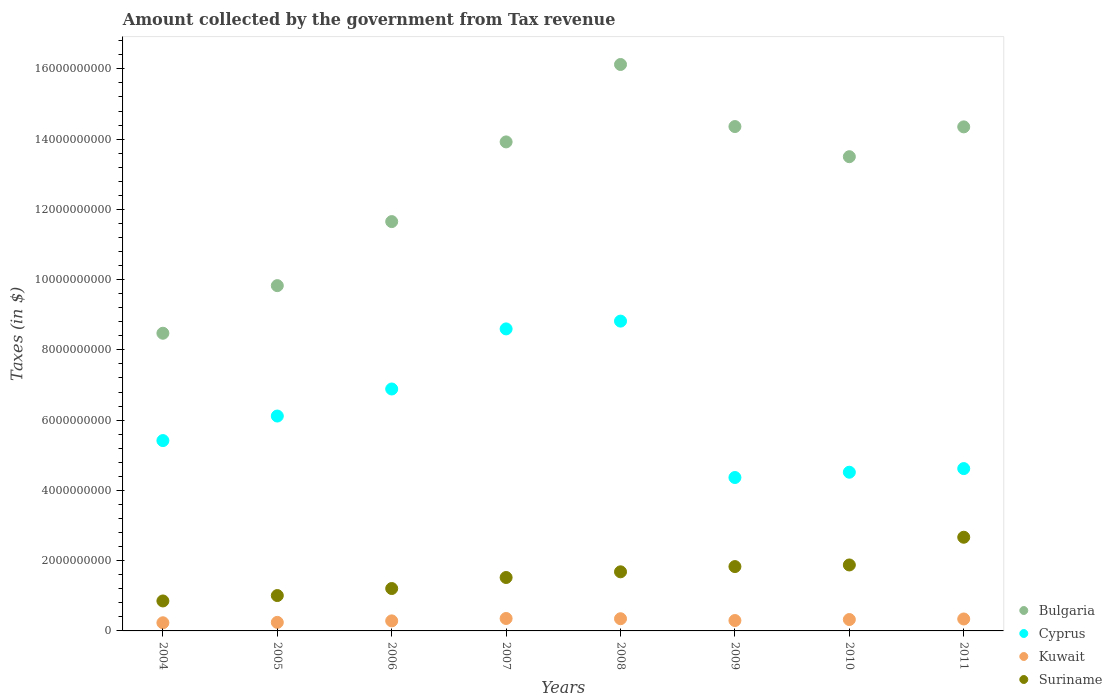Is the number of dotlines equal to the number of legend labels?
Provide a short and direct response. Yes. What is the amount collected by the government from tax revenue in Cyprus in 2008?
Offer a terse response. 8.82e+09. Across all years, what is the maximum amount collected by the government from tax revenue in Kuwait?
Provide a short and direct response. 3.54e+08. Across all years, what is the minimum amount collected by the government from tax revenue in Cyprus?
Provide a succinct answer. 4.37e+09. In which year was the amount collected by the government from tax revenue in Kuwait maximum?
Your answer should be compact. 2007. In which year was the amount collected by the government from tax revenue in Bulgaria minimum?
Offer a very short reply. 2004. What is the total amount collected by the government from tax revenue in Kuwait in the graph?
Your answer should be compact. 2.42e+09. What is the difference between the amount collected by the government from tax revenue in Cyprus in 2004 and that in 2005?
Offer a very short reply. -6.99e+08. What is the difference between the amount collected by the government from tax revenue in Cyprus in 2011 and the amount collected by the government from tax revenue in Kuwait in 2010?
Ensure brevity in your answer.  4.30e+09. What is the average amount collected by the government from tax revenue in Suriname per year?
Offer a terse response. 1.58e+09. In the year 2011, what is the difference between the amount collected by the government from tax revenue in Kuwait and amount collected by the government from tax revenue in Suriname?
Your response must be concise. -2.33e+09. In how many years, is the amount collected by the government from tax revenue in Cyprus greater than 15200000000 $?
Ensure brevity in your answer.  0. What is the ratio of the amount collected by the government from tax revenue in Cyprus in 2006 to that in 2010?
Give a very brief answer. 1.52. Is the amount collected by the government from tax revenue in Bulgaria in 2009 less than that in 2010?
Give a very brief answer. No. What is the difference between the highest and the second highest amount collected by the government from tax revenue in Suriname?
Ensure brevity in your answer.  7.89e+08. What is the difference between the highest and the lowest amount collected by the government from tax revenue in Suriname?
Your answer should be very brief. 1.81e+09. In how many years, is the amount collected by the government from tax revenue in Kuwait greater than the average amount collected by the government from tax revenue in Kuwait taken over all years?
Give a very brief answer. 4. Is the sum of the amount collected by the government from tax revenue in Cyprus in 2005 and 2008 greater than the maximum amount collected by the government from tax revenue in Suriname across all years?
Make the answer very short. Yes. Is it the case that in every year, the sum of the amount collected by the government from tax revenue in Kuwait and amount collected by the government from tax revenue in Cyprus  is greater than the amount collected by the government from tax revenue in Bulgaria?
Make the answer very short. No. Does the amount collected by the government from tax revenue in Bulgaria monotonically increase over the years?
Provide a succinct answer. No. Is the amount collected by the government from tax revenue in Cyprus strictly greater than the amount collected by the government from tax revenue in Kuwait over the years?
Offer a terse response. Yes. Is the amount collected by the government from tax revenue in Bulgaria strictly less than the amount collected by the government from tax revenue in Suriname over the years?
Your response must be concise. No. What is the difference between two consecutive major ticks on the Y-axis?
Your answer should be very brief. 2.00e+09. Are the values on the major ticks of Y-axis written in scientific E-notation?
Offer a terse response. No. Does the graph contain any zero values?
Offer a very short reply. No. Does the graph contain grids?
Provide a succinct answer. No. What is the title of the graph?
Your answer should be very brief. Amount collected by the government from Tax revenue. What is the label or title of the X-axis?
Make the answer very short. Years. What is the label or title of the Y-axis?
Give a very brief answer. Taxes (in $). What is the Taxes (in $) of Bulgaria in 2004?
Provide a succinct answer. 8.47e+09. What is the Taxes (in $) in Cyprus in 2004?
Your answer should be compact. 5.42e+09. What is the Taxes (in $) in Kuwait in 2004?
Provide a succinct answer. 2.32e+08. What is the Taxes (in $) in Suriname in 2004?
Your answer should be compact. 8.53e+08. What is the Taxes (in $) in Bulgaria in 2005?
Offer a very short reply. 9.83e+09. What is the Taxes (in $) of Cyprus in 2005?
Offer a terse response. 6.12e+09. What is the Taxes (in $) of Kuwait in 2005?
Ensure brevity in your answer.  2.43e+08. What is the Taxes (in $) of Suriname in 2005?
Offer a very short reply. 1.01e+09. What is the Taxes (in $) in Bulgaria in 2006?
Give a very brief answer. 1.17e+1. What is the Taxes (in $) of Cyprus in 2006?
Offer a terse response. 6.89e+09. What is the Taxes (in $) in Kuwait in 2006?
Give a very brief answer. 2.86e+08. What is the Taxes (in $) in Suriname in 2006?
Provide a succinct answer. 1.21e+09. What is the Taxes (in $) of Bulgaria in 2007?
Your response must be concise. 1.39e+1. What is the Taxes (in $) of Cyprus in 2007?
Give a very brief answer. 8.60e+09. What is the Taxes (in $) of Kuwait in 2007?
Your answer should be very brief. 3.54e+08. What is the Taxes (in $) of Suriname in 2007?
Offer a very short reply. 1.52e+09. What is the Taxes (in $) of Bulgaria in 2008?
Your response must be concise. 1.61e+1. What is the Taxes (in $) of Cyprus in 2008?
Provide a succinct answer. 8.82e+09. What is the Taxes (in $) of Kuwait in 2008?
Make the answer very short. 3.47e+08. What is the Taxes (in $) of Suriname in 2008?
Offer a very short reply. 1.68e+09. What is the Taxes (in $) of Bulgaria in 2009?
Your answer should be very brief. 1.44e+1. What is the Taxes (in $) in Cyprus in 2009?
Give a very brief answer. 4.37e+09. What is the Taxes (in $) of Kuwait in 2009?
Offer a terse response. 2.96e+08. What is the Taxes (in $) of Suriname in 2009?
Offer a terse response. 1.83e+09. What is the Taxes (in $) of Bulgaria in 2010?
Make the answer very short. 1.35e+1. What is the Taxes (in $) of Cyprus in 2010?
Offer a very short reply. 4.52e+09. What is the Taxes (in $) of Kuwait in 2010?
Provide a short and direct response. 3.24e+08. What is the Taxes (in $) in Suriname in 2010?
Provide a succinct answer. 1.88e+09. What is the Taxes (in $) of Bulgaria in 2011?
Provide a short and direct response. 1.43e+1. What is the Taxes (in $) of Cyprus in 2011?
Offer a very short reply. 4.62e+09. What is the Taxes (in $) in Kuwait in 2011?
Give a very brief answer. 3.40e+08. What is the Taxes (in $) in Suriname in 2011?
Your response must be concise. 2.67e+09. Across all years, what is the maximum Taxes (in $) in Bulgaria?
Ensure brevity in your answer.  1.61e+1. Across all years, what is the maximum Taxes (in $) in Cyprus?
Provide a short and direct response. 8.82e+09. Across all years, what is the maximum Taxes (in $) of Kuwait?
Your response must be concise. 3.54e+08. Across all years, what is the maximum Taxes (in $) in Suriname?
Provide a short and direct response. 2.67e+09. Across all years, what is the minimum Taxes (in $) in Bulgaria?
Your answer should be compact. 8.47e+09. Across all years, what is the minimum Taxes (in $) in Cyprus?
Make the answer very short. 4.37e+09. Across all years, what is the minimum Taxes (in $) of Kuwait?
Give a very brief answer. 2.32e+08. Across all years, what is the minimum Taxes (in $) in Suriname?
Ensure brevity in your answer.  8.53e+08. What is the total Taxes (in $) of Bulgaria in the graph?
Ensure brevity in your answer.  1.02e+11. What is the total Taxes (in $) of Cyprus in the graph?
Your answer should be very brief. 4.93e+1. What is the total Taxes (in $) of Kuwait in the graph?
Give a very brief answer. 2.42e+09. What is the total Taxes (in $) of Suriname in the graph?
Provide a succinct answer. 1.26e+1. What is the difference between the Taxes (in $) of Bulgaria in 2004 and that in 2005?
Provide a short and direct response. -1.36e+09. What is the difference between the Taxes (in $) of Cyprus in 2004 and that in 2005?
Give a very brief answer. -6.99e+08. What is the difference between the Taxes (in $) of Kuwait in 2004 and that in 2005?
Provide a short and direct response. -1.10e+07. What is the difference between the Taxes (in $) in Suriname in 2004 and that in 2005?
Provide a short and direct response. -1.54e+08. What is the difference between the Taxes (in $) of Bulgaria in 2004 and that in 2006?
Offer a very short reply. -3.18e+09. What is the difference between the Taxes (in $) in Cyprus in 2004 and that in 2006?
Make the answer very short. -1.47e+09. What is the difference between the Taxes (in $) in Kuwait in 2004 and that in 2006?
Your response must be concise. -5.40e+07. What is the difference between the Taxes (in $) in Suriname in 2004 and that in 2006?
Your answer should be compact. -3.54e+08. What is the difference between the Taxes (in $) in Bulgaria in 2004 and that in 2007?
Provide a short and direct response. -5.45e+09. What is the difference between the Taxes (in $) of Cyprus in 2004 and that in 2007?
Your answer should be very brief. -3.18e+09. What is the difference between the Taxes (in $) in Kuwait in 2004 and that in 2007?
Keep it short and to the point. -1.22e+08. What is the difference between the Taxes (in $) of Suriname in 2004 and that in 2007?
Offer a very short reply. -6.68e+08. What is the difference between the Taxes (in $) in Bulgaria in 2004 and that in 2008?
Make the answer very short. -7.65e+09. What is the difference between the Taxes (in $) of Cyprus in 2004 and that in 2008?
Make the answer very short. -3.40e+09. What is the difference between the Taxes (in $) of Kuwait in 2004 and that in 2008?
Provide a short and direct response. -1.15e+08. What is the difference between the Taxes (in $) in Suriname in 2004 and that in 2008?
Provide a short and direct response. -8.29e+08. What is the difference between the Taxes (in $) in Bulgaria in 2004 and that in 2009?
Your answer should be compact. -5.88e+09. What is the difference between the Taxes (in $) in Cyprus in 2004 and that in 2009?
Ensure brevity in your answer.  1.05e+09. What is the difference between the Taxes (in $) of Kuwait in 2004 and that in 2009?
Provide a short and direct response. -6.40e+07. What is the difference between the Taxes (in $) in Suriname in 2004 and that in 2009?
Provide a succinct answer. -9.79e+08. What is the difference between the Taxes (in $) in Bulgaria in 2004 and that in 2010?
Give a very brief answer. -5.03e+09. What is the difference between the Taxes (in $) of Cyprus in 2004 and that in 2010?
Make the answer very short. 9.01e+08. What is the difference between the Taxes (in $) in Kuwait in 2004 and that in 2010?
Your answer should be very brief. -9.20e+07. What is the difference between the Taxes (in $) of Suriname in 2004 and that in 2010?
Offer a very short reply. -1.02e+09. What is the difference between the Taxes (in $) of Bulgaria in 2004 and that in 2011?
Your response must be concise. -5.87e+09. What is the difference between the Taxes (in $) in Cyprus in 2004 and that in 2011?
Offer a very short reply. 7.97e+08. What is the difference between the Taxes (in $) of Kuwait in 2004 and that in 2011?
Offer a terse response. -1.08e+08. What is the difference between the Taxes (in $) in Suriname in 2004 and that in 2011?
Your answer should be compact. -1.81e+09. What is the difference between the Taxes (in $) in Bulgaria in 2005 and that in 2006?
Provide a succinct answer. -1.82e+09. What is the difference between the Taxes (in $) of Cyprus in 2005 and that in 2006?
Your answer should be very brief. -7.70e+08. What is the difference between the Taxes (in $) of Kuwait in 2005 and that in 2006?
Provide a short and direct response. -4.30e+07. What is the difference between the Taxes (in $) of Suriname in 2005 and that in 2006?
Ensure brevity in your answer.  -2.00e+08. What is the difference between the Taxes (in $) of Bulgaria in 2005 and that in 2007?
Your answer should be very brief. -4.09e+09. What is the difference between the Taxes (in $) of Cyprus in 2005 and that in 2007?
Your response must be concise. -2.48e+09. What is the difference between the Taxes (in $) in Kuwait in 2005 and that in 2007?
Ensure brevity in your answer.  -1.11e+08. What is the difference between the Taxes (in $) of Suriname in 2005 and that in 2007?
Make the answer very short. -5.14e+08. What is the difference between the Taxes (in $) in Bulgaria in 2005 and that in 2008?
Your answer should be compact. -6.30e+09. What is the difference between the Taxes (in $) in Cyprus in 2005 and that in 2008?
Ensure brevity in your answer.  -2.70e+09. What is the difference between the Taxes (in $) of Kuwait in 2005 and that in 2008?
Ensure brevity in your answer.  -1.04e+08. What is the difference between the Taxes (in $) of Suriname in 2005 and that in 2008?
Your answer should be very brief. -6.76e+08. What is the difference between the Taxes (in $) in Bulgaria in 2005 and that in 2009?
Make the answer very short. -4.53e+09. What is the difference between the Taxes (in $) of Cyprus in 2005 and that in 2009?
Offer a very short reply. 1.75e+09. What is the difference between the Taxes (in $) of Kuwait in 2005 and that in 2009?
Keep it short and to the point. -5.30e+07. What is the difference between the Taxes (in $) in Suriname in 2005 and that in 2009?
Ensure brevity in your answer.  -8.25e+08. What is the difference between the Taxes (in $) of Bulgaria in 2005 and that in 2010?
Offer a very short reply. -3.67e+09. What is the difference between the Taxes (in $) in Cyprus in 2005 and that in 2010?
Keep it short and to the point. 1.60e+09. What is the difference between the Taxes (in $) in Kuwait in 2005 and that in 2010?
Ensure brevity in your answer.  -8.10e+07. What is the difference between the Taxes (in $) of Suriname in 2005 and that in 2010?
Make the answer very short. -8.71e+08. What is the difference between the Taxes (in $) in Bulgaria in 2005 and that in 2011?
Offer a terse response. -4.52e+09. What is the difference between the Taxes (in $) of Cyprus in 2005 and that in 2011?
Offer a very short reply. 1.50e+09. What is the difference between the Taxes (in $) of Kuwait in 2005 and that in 2011?
Provide a succinct answer. -9.70e+07. What is the difference between the Taxes (in $) in Suriname in 2005 and that in 2011?
Your answer should be compact. -1.66e+09. What is the difference between the Taxes (in $) in Bulgaria in 2006 and that in 2007?
Give a very brief answer. -2.27e+09. What is the difference between the Taxes (in $) in Cyprus in 2006 and that in 2007?
Make the answer very short. -1.71e+09. What is the difference between the Taxes (in $) of Kuwait in 2006 and that in 2007?
Make the answer very short. -6.80e+07. What is the difference between the Taxes (in $) of Suriname in 2006 and that in 2007?
Offer a very short reply. -3.14e+08. What is the difference between the Taxes (in $) of Bulgaria in 2006 and that in 2008?
Make the answer very short. -4.47e+09. What is the difference between the Taxes (in $) of Cyprus in 2006 and that in 2008?
Provide a short and direct response. -1.93e+09. What is the difference between the Taxes (in $) of Kuwait in 2006 and that in 2008?
Your answer should be compact. -6.10e+07. What is the difference between the Taxes (in $) of Suriname in 2006 and that in 2008?
Offer a terse response. -4.76e+08. What is the difference between the Taxes (in $) in Bulgaria in 2006 and that in 2009?
Offer a very short reply. -2.71e+09. What is the difference between the Taxes (in $) of Cyprus in 2006 and that in 2009?
Your answer should be compact. 2.52e+09. What is the difference between the Taxes (in $) in Kuwait in 2006 and that in 2009?
Ensure brevity in your answer.  -1.00e+07. What is the difference between the Taxes (in $) in Suriname in 2006 and that in 2009?
Provide a short and direct response. -6.25e+08. What is the difference between the Taxes (in $) of Bulgaria in 2006 and that in 2010?
Give a very brief answer. -1.85e+09. What is the difference between the Taxes (in $) of Cyprus in 2006 and that in 2010?
Your answer should be very brief. 2.37e+09. What is the difference between the Taxes (in $) of Kuwait in 2006 and that in 2010?
Offer a terse response. -3.80e+07. What is the difference between the Taxes (in $) in Suriname in 2006 and that in 2010?
Your answer should be very brief. -6.71e+08. What is the difference between the Taxes (in $) of Bulgaria in 2006 and that in 2011?
Give a very brief answer. -2.70e+09. What is the difference between the Taxes (in $) in Cyprus in 2006 and that in 2011?
Keep it short and to the point. 2.27e+09. What is the difference between the Taxes (in $) in Kuwait in 2006 and that in 2011?
Your answer should be very brief. -5.40e+07. What is the difference between the Taxes (in $) in Suriname in 2006 and that in 2011?
Make the answer very short. -1.46e+09. What is the difference between the Taxes (in $) in Bulgaria in 2007 and that in 2008?
Make the answer very short. -2.20e+09. What is the difference between the Taxes (in $) in Cyprus in 2007 and that in 2008?
Your response must be concise. -2.21e+08. What is the difference between the Taxes (in $) of Suriname in 2007 and that in 2008?
Make the answer very short. -1.62e+08. What is the difference between the Taxes (in $) of Bulgaria in 2007 and that in 2009?
Your answer should be compact. -4.37e+08. What is the difference between the Taxes (in $) in Cyprus in 2007 and that in 2009?
Give a very brief answer. 4.23e+09. What is the difference between the Taxes (in $) in Kuwait in 2007 and that in 2009?
Give a very brief answer. 5.80e+07. What is the difference between the Taxes (in $) in Suriname in 2007 and that in 2009?
Your answer should be very brief. -3.11e+08. What is the difference between the Taxes (in $) in Bulgaria in 2007 and that in 2010?
Give a very brief answer. 4.21e+08. What is the difference between the Taxes (in $) of Cyprus in 2007 and that in 2010?
Give a very brief answer. 4.08e+09. What is the difference between the Taxes (in $) of Kuwait in 2007 and that in 2010?
Your answer should be compact. 3.00e+07. What is the difference between the Taxes (in $) of Suriname in 2007 and that in 2010?
Offer a terse response. -3.57e+08. What is the difference between the Taxes (in $) in Bulgaria in 2007 and that in 2011?
Give a very brief answer. -4.28e+08. What is the difference between the Taxes (in $) in Cyprus in 2007 and that in 2011?
Your response must be concise. 3.98e+09. What is the difference between the Taxes (in $) of Kuwait in 2007 and that in 2011?
Provide a short and direct response. 1.40e+07. What is the difference between the Taxes (in $) of Suriname in 2007 and that in 2011?
Your answer should be very brief. -1.15e+09. What is the difference between the Taxes (in $) in Bulgaria in 2008 and that in 2009?
Offer a terse response. 1.77e+09. What is the difference between the Taxes (in $) in Cyprus in 2008 and that in 2009?
Make the answer very short. 4.45e+09. What is the difference between the Taxes (in $) of Kuwait in 2008 and that in 2009?
Your response must be concise. 5.10e+07. What is the difference between the Taxes (in $) of Suriname in 2008 and that in 2009?
Keep it short and to the point. -1.49e+08. What is the difference between the Taxes (in $) of Bulgaria in 2008 and that in 2010?
Your answer should be compact. 2.62e+09. What is the difference between the Taxes (in $) in Cyprus in 2008 and that in 2010?
Provide a short and direct response. 4.30e+09. What is the difference between the Taxes (in $) of Kuwait in 2008 and that in 2010?
Your answer should be compact. 2.30e+07. What is the difference between the Taxes (in $) in Suriname in 2008 and that in 2010?
Offer a terse response. -1.95e+08. What is the difference between the Taxes (in $) in Bulgaria in 2008 and that in 2011?
Your response must be concise. 1.78e+09. What is the difference between the Taxes (in $) in Cyprus in 2008 and that in 2011?
Ensure brevity in your answer.  4.20e+09. What is the difference between the Taxes (in $) of Suriname in 2008 and that in 2011?
Your answer should be very brief. -9.84e+08. What is the difference between the Taxes (in $) in Bulgaria in 2009 and that in 2010?
Your response must be concise. 8.58e+08. What is the difference between the Taxes (in $) of Cyprus in 2009 and that in 2010?
Offer a terse response. -1.51e+08. What is the difference between the Taxes (in $) of Kuwait in 2009 and that in 2010?
Offer a terse response. -2.80e+07. What is the difference between the Taxes (in $) of Suriname in 2009 and that in 2010?
Keep it short and to the point. -4.60e+07. What is the difference between the Taxes (in $) of Bulgaria in 2009 and that in 2011?
Your answer should be very brief. 9.09e+06. What is the difference between the Taxes (in $) in Cyprus in 2009 and that in 2011?
Give a very brief answer. -2.54e+08. What is the difference between the Taxes (in $) of Kuwait in 2009 and that in 2011?
Ensure brevity in your answer.  -4.40e+07. What is the difference between the Taxes (in $) in Suriname in 2009 and that in 2011?
Provide a short and direct response. -8.35e+08. What is the difference between the Taxes (in $) of Bulgaria in 2010 and that in 2011?
Offer a terse response. -8.49e+08. What is the difference between the Taxes (in $) in Cyprus in 2010 and that in 2011?
Offer a terse response. -1.04e+08. What is the difference between the Taxes (in $) in Kuwait in 2010 and that in 2011?
Make the answer very short. -1.60e+07. What is the difference between the Taxes (in $) of Suriname in 2010 and that in 2011?
Offer a terse response. -7.89e+08. What is the difference between the Taxes (in $) of Bulgaria in 2004 and the Taxes (in $) of Cyprus in 2005?
Offer a terse response. 2.36e+09. What is the difference between the Taxes (in $) in Bulgaria in 2004 and the Taxes (in $) in Kuwait in 2005?
Your response must be concise. 8.23e+09. What is the difference between the Taxes (in $) in Bulgaria in 2004 and the Taxes (in $) in Suriname in 2005?
Your response must be concise. 7.47e+09. What is the difference between the Taxes (in $) of Cyprus in 2004 and the Taxes (in $) of Kuwait in 2005?
Your response must be concise. 5.18e+09. What is the difference between the Taxes (in $) in Cyprus in 2004 and the Taxes (in $) in Suriname in 2005?
Ensure brevity in your answer.  4.41e+09. What is the difference between the Taxes (in $) of Kuwait in 2004 and the Taxes (in $) of Suriname in 2005?
Ensure brevity in your answer.  -7.75e+08. What is the difference between the Taxes (in $) in Bulgaria in 2004 and the Taxes (in $) in Cyprus in 2006?
Ensure brevity in your answer.  1.59e+09. What is the difference between the Taxes (in $) of Bulgaria in 2004 and the Taxes (in $) of Kuwait in 2006?
Your answer should be compact. 8.19e+09. What is the difference between the Taxes (in $) of Bulgaria in 2004 and the Taxes (in $) of Suriname in 2006?
Offer a terse response. 7.27e+09. What is the difference between the Taxes (in $) of Cyprus in 2004 and the Taxes (in $) of Kuwait in 2006?
Make the answer very short. 5.13e+09. What is the difference between the Taxes (in $) in Cyprus in 2004 and the Taxes (in $) in Suriname in 2006?
Give a very brief answer. 4.21e+09. What is the difference between the Taxes (in $) of Kuwait in 2004 and the Taxes (in $) of Suriname in 2006?
Offer a very short reply. -9.75e+08. What is the difference between the Taxes (in $) in Bulgaria in 2004 and the Taxes (in $) in Cyprus in 2007?
Give a very brief answer. -1.24e+08. What is the difference between the Taxes (in $) in Bulgaria in 2004 and the Taxes (in $) in Kuwait in 2007?
Your answer should be very brief. 8.12e+09. What is the difference between the Taxes (in $) in Bulgaria in 2004 and the Taxes (in $) in Suriname in 2007?
Your answer should be compact. 6.95e+09. What is the difference between the Taxes (in $) in Cyprus in 2004 and the Taxes (in $) in Kuwait in 2007?
Give a very brief answer. 5.06e+09. What is the difference between the Taxes (in $) of Cyprus in 2004 and the Taxes (in $) of Suriname in 2007?
Keep it short and to the point. 3.90e+09. What is the difference between the Taxes (in $) of Kuwait in 2004 and the Taxes (in $) of Suriname in 2007?
Your answer should be compact. -1.29e+09. What is the difference between the Taxes (in $) in Bulgaria in 2004 and the Taxes (in $) in Cyprus in 2008?
Give a very brief answer. -3.45e+08. What is the difference between the Taxes (in $) of Bulgaria in 2004 and the Taxes (in $) of Kuwait in 2008?
Your response must be concise. 8.13e+09. What is the difference between the Taxes (in $) in Bulgaria in 2004 and the Taxes (in $) in Suriname in 2008?
Provide a short and direct response. 6.79e+09. What is the difference between the Taxes (in $) of Cyprus in 2004 and the Taxes (in $) of Kuwait in 2008?
Your response must be concise. 5.07e+09. What is the difference between the Taxes (in $) of Cyprus in 2004 and the Taxes (in $) of Suriname in 2008?
Keep it short and to the point. 3.74e+09. What is the difference between the Taxes (in $) in Kuwait in 2004 and the Taxes (in $) in Suriname in 2008?
Offer a very short reply. -1.45e+09. What is the difference between the Taxes (in $) in Bulgaria in 2004 and the Taxes (in $) in Cyprus in 2009?
Ensure brevity in your answer.  4.11e+09. What is the difference between the Taxes (in $) in Bulgaria in 2004 and the Taxes (in $) in Kuwait in 2009?
Offer a terse response. 8.18e+09. What is the difference between the Taxes (in $) in Bulgaria in 2004 and the Taxes (in $) in Suriname in 2009?
Give a very brief answer. 6.64e+09. What is the difference between the Taxes (in $) in Cyprus in 2004 and the Taxes (in $) in Kuwait in 2009?
Offer a terse response. 5.12e+09. What is the difference between the Taxes (in $) of Cyprus in 2004 and the Taxes (in $) of Suriname in 2009?
Ensure brevity in your answer.  3.59e+09. What is the difference between the Taxes (in $) of Kuwait in 2004 and the Taxes (in $) of Suriname in 2009?
Your response must be concise. -1.60e+09. What is the difference between the Taxes (in $) in Bulgaria in 2004 and the Taxes (in $) in Cyprus in 2010?
Provide a short and direct response. 3.96e+09. What is the difference between the Taxes (in $) in Bulgaria in 2004 and the Taxes (in $) in Kuwait in 2010?
Your answer should be very brief. 8.15e+09. What is the difference between the Taxes (in $) in Bulgaria in 2004 and the Taxes (in $) in Suriname in 2010?
Provide a succinct answer. 6.60e+09. What is the difference between the Taxes (in $) in Cyprus in 2004 and the Taxes (in $) in Kuwait in 2010?
Your response must be concise. 5.09e+09. What is the difference between the Taxes (in $) in Cyprus in 2004 and the Taxes (in $) in Suriname in 2010?
Your answer should be very brief. 3.54e+09. What is the difference between the Taxes (in $) in Kuwait in 2004 and the Taxes (in $) in Suriname in 2010?
Provide a short and direct response. -1.65e+09. What is the difference between the Taxes (in $) in Bulgaria in 2004 and the Taxes (in $) in Cyprus in 2011?
Your answer should be very brief. 3.85e+09. What is the difference between the Taxes (in $) in Bulgaria in 2004 and the Taxes (in $) in Kuwait in 2011?
Your answer should be compact. 8.13e+09. What is the difference between the Taxes (in $) of Bulgaria in 2004 and the Taxes (in $) of Suriname in 2011?
Your answer should be compact. 5.81e+09. What is the difference between the Taxes (in $) in Cyprus in 2004 and the Taxes (in $) in Kuwait in 2011?
Keep it short and to the point. 5.08e+09. What is the difference between the Taxes (in $) of Cyprus in 2004 and the Taxes (in $) of Suriname in 2011?
Provide a short and direct response. 2.75e+09. What is the difference between the Taxes (in $) of Kuwait in 2004 and the Taxes (in $) of Suriname in 2011?
Give a very brief answer. -2.43e+09. What is the difference between the Taxes (in $) in Bulgaria in 2005 and the Taxes (in $) in Cyprus in 2006?
Offer a very short reply. 2.94e+09. What is the difference between the Taxes (in $) of Bulgaria in 2005 and the Taxes (in $) of Kuwait in 2006?
Offer a very short reply. 9.54e+09. What is the difference between the Taxes (in $) in Bulgaria in 2005 and the Taxes (in $) in Suriname in 2006?
Your response must be concise. 8.62e+09. What is the difference between the Taxes (in $) of Cyprus in 2005 and the Taxes (in $) of Kuwait in 2006?
Give a very brief answer. 5.83e+09. What is the difference between the Taxes (in $) in Cyprus in 2005 and the Taxes (in $) in Suriname in 2006?
Ensure brevity in your answer.  4.91e+09. What is the difference between the Taxes (in $) in Kuwait in 2005 and the Taxes (in $) in Suriname in 2006?
Your answer should be very brief. -9.64e+08. What is the difference between the Taxes (in $) in Bulgaria in 2005 and the Taxes (in $) in Cyprus in 2007?
Provide a succinct answer. 1.23e+09. What is the difference between the Taxes (in $) in Bulgaria in 2005 and the Taxes (in $) in Kuwait in 2007?
Provide a succinct answer. 9.48e+09. What is the difference between the Taxes (in $) in Bulgaria in 2005 and the Taxes (in $) in Suriname in 2007?
Ensure brevity in your answer.  8.31e+09. What is the difference between the Taxes (in $) of Cyprus in 2005 and the Taxes (in $) of Kuwait in 2007?
Offer a terse response. 5.76e+09. What is the difference between the Taxes (in $) in Cyprus in 2005 and the Taxes (in $) in Suriname in 2007?
Ensure brevity in your answer.  4.60e+09. What is the difference between the Taxes (in $) of Kuwait in 2005 and the Taxes (in $) of Suriname in 2007?
Your answer should be compact. -1.28e+09. What is the difference between the Taxes (in $) in Bulgaria in 2005 and the Taxes (in $) in Cyprus in 2008?
Ensure brevity in your answer.  1.01e+09. What is the difference between the Taxes (in $) of Bulgaria in 2005 and the Taxes (in $) of Kuwait in 2008?
Keep it short and to the point. 9.48e+09. What is the difference between the Taxes (in $) in Bulgaria in 2005 and the Taxes (in $) in Suriname in 2008?
Ensure brevity in your answer.  8.15e+09. What is the difference between the Taxes (in $) of Cyprus in 2005 and the Taxes (in $) of Kuwait in 2008?
Offer a terse response. 5.77e+09. What is the difference between the Taxes (in $) in Cyprus in 2005 and the Taxes (in $) in Suriname in 2008?
Provide a short and direct response. 4.43e+09. What is the difference between the Taxes (in $) of Kuwait in 2005 and the Taxes (in $) of Suriname in 2008?
Your answer should be very brief. -1.44e+09. What is the difference between the Taxes (in $) in Bulgaria in 2005 and the Taxes (in $) in Cyprus in 2009?
Provide a succinct answer. 5.46e+09. What is the difference between the Taxes (in $) in Bulgaria in 2005 and the Taxes (in $) in Kuwait in 2009?
Ensure brevity in your answer.  9.53e+09. What is the difference between the Taxes (in $) in Bulgaria in 2005 and the Taxes (in $) in Suriname in 2009?
Keep it short and to the point. 8.00e+09. What is the difference between the Taxes (in $) of Cyprus in 2005 and the Taxes (in $) of Kuwait in 2009?
Ensure brevity in your answer.  5.82e+09. What is the difference between the Taxes (in $) of Cyprus in 2005 and the Taxes (in $) of Suriname in 2009?
Make the answer very short. 4.29e+09. What is the difference between the Taxes (in $) in Kuwait in 2005 and the Taxes (in $) in Suriname in 2009?
Offer a very short reply. -1.59e+09. What is the difference between the Taxes (in $) in Bulgaria in 2005 and the Taxes (in $) in Cyprus in 2010?
Provide a short and direct response. 5.31e+09. What is the difference between the Taxes (in $) of Bulgaria in 2005 and the Taxes (in $) of Kuwait in 2010?
Make the answer very short. 9.51e+09. What is the difference between the Taxes (in $) in Bulgaria in 2005 and the Taxes (in $) in Suriname in 2010?
Provide a succinct answer. 7.95e+09. What is the difference between the Taxes (in $) of Cyprus in 2005 and the Taxes (in $) of Kuwait in 2010?
Offer a terse response. 5.79e+09. What is the difference between the Taxes (in $) in Cyprus in 2005 and the Taxes (in $) in Suriname in 2010?
Keep it short and to the point. 4.24e+09. What is the difference between the Taxes (in $) of Kuwait in 2005 and the Taxes (in $) of Suriname in 2010?
Ensure brevity in your answer.  -1.63e+09. What is the difference between the Taxes (in $) in Bulgaria in 2005 and the Taxes (in $) in Cyprus in 2011?
Keep it short and to the point. 5.21e+09. What is the difference between the Taxes (in $) in Bulgaria in 2005 and the Taxes (in $) in Kuwait in 2011?
Keep it short and to the point. 9.49e+09. What is the difference between the Taxes (in $) of Bulgaria in 2005 and the Taxes (in $) of Suriname in 2011?
Keep it short and to the point. 7.16e+09. What is the difference between the Taxes (in $) in Cyprus in 2005 and the Taxes (in $) in Kuwait in 2011?
Your answer should be very brief. 5.78e+09. What is the difference between the Taxes (in $) in Cyprus in 2005 and the Taxes (in $) in Suriname in 2011?
Make the answer very short. 3.45e+09. What is the difference between the Taxes (in $) of Kuwait in 2005 and the Taxes (in $) of Suriname in 2011?
Your answer should be compact. -2.42e+09. What is the difference between the Taxes (in $) in Bulgaria in 2006 and the Taxes (in $) in Cyprus in 2007?
Provide a succinct answer. 3.05e+09. What is the difference between the Taxes (in $) of Bulgaria in 2006 and the Taxes (in $) of Kuwait in 2007?
Provide a short and direct response. 1.13e+1. What is the difference between the Taxes (in $) in Bulgaria in 2006 and the Taxes (in $) in Suriname in 2007?
Keep it short and to the point. 1.01e+1. What is the difference between the Taxes (in $) in Cyprus in 2006 and the Taxes (in $) in Kuwait in 2007?
Your answer should be compact. 6.53e+09. What is the difference between the Taxes (in $) of Cyprus in 2006 and the Taxes (in $) of Suriname in 2007?
Offer a terse response. 5.37e+09. What is the difference between the Taxes (in $) in Kuwait in 2006 and the Taxes (in $) in Suriname in 2007?
Offer a terse response. -1.23e+09. What is the difference between the Taxes (in $) in Bulgaria in 2006 and the Taxes (in $) in Cyprus in 2008?
Keep it short and to the point. 2.83e+09. What is the difference between the Taxes (in $) in Bulgaria in 2006 and the Taxes (in $) in Kuwait in 2008?
Your response must be concise. 1.13e+1. What is the difference between the Taxes (in $) in Bulgaria in 2006 and the Taxes (in $) in Suriname in 2008?
Ensure brevity in your answer.  9.97e+09. What is the difference between the Taxes (in $) in Cyprus in 2006 and the Taxes (in $) in Kuwait in 2008?
Provide a succinct answer. 6.54e+09. What is the difference between the Taxes (in $) in Cyprus in 2006 and the Taxes (in $) in Suriname in 2008?
Provide a succinct answer. 5.20e+09. What is the difference between the Taxes (in $) of Kuwait in 2006 and the Taxes (in $) of Suriname in 2008?
Provide a short and direct response. -1.40e+09. What is the difference between the Taxes (in $) of Bulgaria in 2006 and the Taxes (in $) of Cyprus in 2009?
Make the answer very short. 7.29e+09. What is the difference between the Taxes (in $) in Bulgaria in 2006 and the Taxes (in $) in Kuwait in 2009?
Ensure brevity in your answer.  1.14e+1. What is the difference between the Taxes (in $) of Bulgaria in 2006 and the Taxes (in $) of Suriname in 2009?
Provide a short and direct response. 9.82e+09. What is the difference between the Taxes (in $) of Cyprus in 2006 and the Taxes (in $) of Kuwait in 2009?
Make the answer very short. 6.59e+09. What is the difference between the Taxes (in $) in Cyprus in 2006 and the Taxes (in $) in Suriname in 2009?
Your answer should be very brief. 5.06e+09. What is the difference between the Taxes (in $) in Kuwait in 2006 and the Taxes (in $) in Suriname in 2009?
Provide a succinct answer. -1.55e+09. What is the difference between the Taxes (in $) in Bulgaria in 2006 and the Taxes (in $) in Cyprus in 2010?
Give a very brief answer. 7.13e+09. What is the difference between the Taxes (in $) of Bulgaria in 2006 and the Taxes (in $) of Kuwait in 2010?
Offer a very short reply. 1.13e+1. What is the difference between the Taxes (in $) of Bulgaria in 2006 and the Taxes (in $) of Suriname in 2010?
Your answer should be very brief. 9.77e+09. What is the difference between the Taxes (in $) of Cyprus in 2006 and the Taxes (in $) of Kuwait in 2010?
Offer a terse response. 6.56e+09. What is the difference between the Taxes (in $) of Cyprus in 2006 and the Taxes (in $) of Suriname in 2010?
Ensure brevity in your answer.  5.01e+09. What is the difference between the Taxes (in $) in Kuwait in 2006 and the Taxes (in $) in Suriname in 2010?
Your answer should be compact. -1.59e+09. What is the difference between the Taxes (in $) of Bulgaria in 2006 and the Taxes (in $) of Cyprus in 2011?
Offer a terse response. 7.03e+09. What is the difference between the Taxes (in $) in Bulgaria in 2006 and the Taxes (in $) in Kuwait in 2011?
Offer a very short reply. 1.13e+1. What is the difference between the Taxes (in $) of Bulgaria in 2006 and the Taxes (in $) of Suriname in 2011?
Offer a very short reply. 8.99e+09. What is the difference between the Taxes (in $) of Cyprus in 2006 and the Taxes (in $) of Kuwait in 2011?
Offer a terse response. 6.55e+09. What is the difference between the Taxes (in $) in Cyprus in 2006 and the Taxes (in $) in Suriname in 2011?
Provide a short and direct response. 4.22e+09. What is the difference between the Taxes (in $) of Kuwait in 2006 and the Taxes (in $) of Suriname in 2011?
Offer a terse response. -2.38e+09. What is the difference between the Taxes (in $) in Bulgaria in 2007 and the Taxes (in $) in Cyprus in 2008?
Provide a succinct answer. 5.10e+09. What is the difference between the Taxes (in $) of Bulgaria in 2007 and the Taxes (in $) of Kuwait in 2008?
Give a very brief answer. 1.36e+1. What is the difference between the Taxes (in $) in Bulgaria in 2007 and the Taxes (in $) in Suriname in 2008?
Your answer should be compact. 1.22e+1. What is the difference between the Taxes (in $) of Cyprus in 2007 and the Taxes (in $) of Kuwait in 2008?
Your answer should be very brief. 8.25e+09. What is the difference between the Taxes (in $) in Cyprus in 2007 and the Taxes (in $) in Suriname in 2008?
Your answer should be compact. 6.92e+09. What is the difference between the Taxes (in $) in Kuwait in 2007 and the Taxes (in $) in Suriname in 2008?
Make the answer very short. -1.33e+09. What is the difference between the Taxes (in $) in Bulgaria in 2007 and the Taxes (in $) in Cyprus in 2009?
Your answer should be very brief. 9.55e+09. What is the difference between the Taxes (in $) of Bulgaria in 2007 and the Taxes (in $) of Kuwait in 2009?
Your answer should be very brief. 1.36e+1. What is the difference between the Taxes (in $) in Bulgaria in 2007 and the Taxes (in $) in Suriname in 2009?
Offer a very short reply. 1.21e+1. What is the difference between the Taxes (in $) of Cyprus in 2007 and the Taxes (in $) of Kuwait in 2009?
Give a very brief answer. 8.30e+09. What is the difference between the Taxes (in $) of Cyprus in 2007 and the Taxes (in $) of Suriname in 2009?
Your answer should be compact. 6.77e+09. What is the difference between the Taxes (in $) of Kuwait in 2007 and the Taxes (in $) of Suriname in 2009?
Offer a terse response. -1.48e+09. What is the difference between the Taxes (in $) in Bulgaria in 2007 and the Taxes (in $) in Cyprus in 2010?
Offer a very short reply. 9.40e+09. What is the difference between the Taxes (in $) of Bulgaria in 2007 and the Taxes (in $) of Kuwait in 2010?
Make the answer very short. 1.36e+1. What is the difference between the Taxes (in $) of Bulgaria in 2007 and the Taxes (in $) of Suriname in 2010?
Make the answer very short. 1.20e+1. What is the difference between the Taxes (in $) in Cyprus in 2007 and the Taxes (in $) in Kuwait in 2010?
Your answer should be compact. 8.27e+09. What is the difference between the Taxes (in $) in Cyprus in 2007 and the Taxes (in $) in Suriname in 2010?
Provide a succinct answer. 6.72e+09. What is the difference between the Taxes (in $) of Kuwait in 2007 and the Taxes (in $) of Suriname in 2010?
Provide a succinct answer. -1.52e+09. What is the difference between the Taxes (in $) in Bulgaria in 2007 and the Taxes (in $) in Cyprus in 2011?
Your response must be concise. 9.30e+09. What is the difference between the Taxes (in $) of Bulgaria in 2007 and the Taxes (in $) of Kuwait in 2011?
Make the answer very short. 1.36e+1. What is the difference between the Taxes (in $) in Bulgaria in 2007 and the Taxes (in $) in Suriname in 2011?
Make the answer very short. 1.13e+1. What is the difference between the Taxes (in $) of Cyprus in 2007 and the Taxes (in $) of Kuwait in 2011?
Offer a terse response. 8.26e+09. What is the difference between the Taxes (in $) of Cyprus in 2007 and the Taxes (in $) of Suriname in 2011?
Your answer should be very brief. 5.93e+09. What is the difference between the Taxes (in $) in Kuwait in 2007 and the Taxes (in $) in Suriname in 2011?
Provide a short and direct response. -2.31e+09. What is the difference between the Taxes (in $) of Bulgaria in 2008 and the Taxes (in $) of Cyprus in 2009?
Your answer should be compact. 1.18e+1. What is the difference between the Taxes (in $) in Bulgaria in 2008 and the Taxes (in $) in Kuwait in 2009?
Your answer should be compact. 1.58e+1. What is the difference between the Taxes (in $) of Bulgaria in 2008 and the Taxes (in $) of Suriname in 2009?
Offer a very short reply. 1.43e+1. What is the difference between the Taxes (in $) in Cyprus in 2008 and the Taxes (in $) in Kuwait in 2009?
Offer a very short reply. 8.52e+09. What is the difference between the Taxes (in $) of Cyprus in 2008 and the Taxes (in $) of Suriname in 2009?
Your answer should be compact. 6.99e+09. What is the difference between the Taxes (in $) in Kuwait in 2008 and the Taxes (in $) in Suriname in 2009?
Offer a terse response. -1.48e+09. What is the difference between the Taxes (in $) of Bulgaria in 2008 and the Taxes (in $) of Cyprus in 2010?
Offer a very short reply. 1.16e+1. What is the difference between the Taxes (in $) in Bulgaria in 2008 and the Taxes (in $) in Kuwait in 2010?
Offer a very short reply. 1.58e+1. What is the difference between the Taxes (in $) in Bulgaria in 2008 and the Taxes (in $) in Suriname in 2010?
Your response must be concise. 1.42e+1. What is the difference between the Taxes (in $) of Cyprus in 2008 and the Taxes (in $) of Kuwait in 2010?
Ensure brevity in your answer.  8.50e+09. What is the difference between the Taxes (in $) in Cyprus in 2008 and the Taxes (in $) in Suriname in 2010?
Make the answer very short. 6.94e+09. What is the difference between the Taxes (in $) of Kuwait in 2008 and the Taxes (in $) of Suriname in 2010?
Make the answer very short. -1.53e+09. What is the difference between the Taxes (in $) in Bulgaria in 2008 and the Taxes (in $) in Cyprus in 2011?
Provide a succinct answer. 1.15e+1. What is the difference between the Taxes (in $) of Bulgaria in 2008 and the Taxes (in $) of Kuwait in 2011?
Keep it short and to the point. 1.58e+1. What is the difference between the Taxes (in $) of Bulgaria in 2008 and the Taxes (in $) of Suriname in 2011?
Offer a very short reply. 1.35e+1. What is the difference between the Taxes (in $) in Cyprus in 2008 and the Taxes (in $) in Kuwait in 2011?
Make the answer very short. 8.48e+09. What is the difference between the Taxes (in $) in Cyprus in 2008 and the Taxes (in $) in Suriname in 2011?
Your answer should be very brief. 6.15e+09. What is the difference between the Taxes (in $) in Kuwait in 2008 and the Taxes (in $) in Suriname in 2011?
Provide a short and direct response. -2.32e+09. What is the difference between the Taxes (in $) of Bulgaria in 2009 and the Taxes (in $) of Cyprus in 2010?
Ensure brevity in your answer.  9.84e+09. What is the difference between the Taxes (in $) of Bulgaria in 2009 and the Taxes (in $) of Kuwait in 2010?
Provide a succinct answer. 1.40e+1. What is the difference between the Taxes (in $) in Bulgaria in 2009 and the Taxes (in $) in Suriname in 2010?
Give a very brief answer. 1.25e+1. What is the difference between the Taxes (in $) of Cyprus in 2009 and the Taxes (in $) of Kuwait in 2010?
Offer a very short reply. 4.04e+09. What is the difference between the Taxes (in $) in Cyprus in 2009 and the Taxes (in $) in Suriname in 2010?
Offer a terse response. 2.49e+09. What is the difference between the Taxes (in $) of Kuwait in 2009 and the Taxes (in $) of Suriname in 2010?
Your answer should be compact. -1.58e+09. What is the difference between the Taxes (in $) in Bulgaria in 2009 and the Taxes (in $) in Cyprus in 2011?
Your answer should be very brief. 9.74e+09. What is the difference between the Taxes (in $) of Bulgaria in 2009 and the Taxes (in $) of Kuwait in 2011?
Offer a very short reply. 1.40e+1. What is the difference between the Taxes (in $) in Bulgaria in 2009 and the Taxes (in $) in Suriname in 2011?
Provide a succinct answer. 1.17e+1. What is the difference between the Taxes (in $) in Cyprus in 2009 and the Taxes (in $) in Kuwait in 2011?
Provide a short and direct response. 4.03e+09. What is the difference between the Taxes (in $) in Cyprus in 2009 and the Taxes (in $) in Suriname in 2011?
Your answer should be very brief. 1.70e+09. What is the difference between the Taxes (in $) in Kuwait in 2009 and the Taxes (in $) in Suriname in 2011?
Offer a very short reply. -2.37e+09. What is the difference between the Taxes (in $) in Bulgaria in 2010 and the Taxes (in $) in Cyprus in 2011?
Your answer should be compact. 8.88e+09. What is the difference between the Taxes (in $) in Bulgaria in 2010 and the Taxes (in $) in Kuwait in 2011?
Your answer should be compact. 1.32e+1. What is the difference between the Taxes (in $) of Bulgaria in 2010 and the Taxes (in $) of Suriname in 2011?
Give a very brief answer. 1.08e+1. What is the difference between the Taxes (in $) in Cyprus in 2010 and the Taxes (in $) in Kuwait in 2011?
Provide a short and direct response. 4.18e+09. What is the difference between the Taxes (in $) of Cyprus in 2010 and the Taxes (in $) of Suriname in 2011?
Keep it short and to the point. 1.85e+09. What is the difference between the Taxes (in $) of Kuwait in 2010 and the Taxes (in $) of Suriname in 2011?
Offer a terse response. -2.34e+09. What is the average Taxes (in $) in Bulgaria per year?
Provide a succinct answer. 1.28e+1. What is the average Taxes (in $) of Cyprus per year?
Provide a succinct answer. 6.17e+09. What is the average Taxes (in $) in Kuwait per year?
Keep it short and to the point. 3.03e+08. What is the average Taxes (in $) in Suriname per year?
Your answer should be very brief. 1.58e+09. In the year 2004, what is the difference between the Taxes (in $) in Bulgaria and Taxes (in $) in Cyprus?
Your response must be concise. 3.06e+09. In the year 2004, what is the difference between the Taxes (in $) in Bulgaria and Taxes (in $) in Kuwait?
Offer a very short reply. 8.24e+09. In the year 2004, what is the difference between the Taxes (in $) of Bulgaria and Taxes (in $) of Suriname?
Your answer should be very brief. 7.62e+09. In the year 2004, what is the difference between the Taxes (in $) of Cyprus and Taxes (in $) of Kuwait?
Give a very brief answer. 5.19e+09. In the year 2004, what is the difference between the Taxes (in $) in Cyprus and Taxes (in $) in Suriname?
Keep it short and to the point. 4.57e+09. In the year 2004, what is the difference between the Taxes (in $) of Kuwait and Taxes (in $) of Suriname?
Your answer should be compact. -6.21e+08. In the year 2005, what is the difference between the Taxes (in $) of Bulgaria and Taxes (in $) of Cyprus?
Your answer should be compact. 3.71e+09. In the year 2005, what is the difference between the Taxes (in $) of Bulgaria and Taxes (in $) of Kuwait?
Ensure brevity in your answer.  9.59e+09. In the year 2005, what is the difference between the Taxes (in $) in Bulgaria and Taxes (in $) in Suriname?
Provide a succinct answer. 8.82e+09. In the year 2005, what is the difference between the Taxes (in $) of Cyprus and Taxes (in $) of Kuwait?
Ensure brevity in your answer.  5.87e+09. In the year 2005, what is the difference between the Taxes (in $) in Cyprus and Taxes (in $) in Suriname?
Ensure brevity in your answer.  5.11e+09. In the year 2005, what is the difference between the Taxes (in $) of Kuwait and Taxes (in $) of Suriname?
Offer a terse response. -7.64e+08. In the year 2006, what is the difference between the Taxes (in $) of Bulgaria and Taxes (in $) of Cyprus?
Give a very brief answer. 4.77e+09. In the year 2006, what is the difference between the Taxes (in $) of Bulgaria and Taxes (in $) of Kuwait?
Your answer should be compact. 1.14e+1. In the year 2006, what is the difference between the Taxes (in $) in Bulgaria and Taxes (in $) in Suriname?
Give a very brief answer. 1.04e+1. In the year 2006, what is the difference between the Taxes (in $) in Cyprus and Taxes (in $) in Kuwait?
Give a very brief answer. 6.60e+09. In the year 2006, what is the difference between the Taxes (in $) in Cyprus and Taxes (in $) in Suriname?
Ensure brevity in your answer.  5.68e+09. In the year 2006, what is the difference between the Taxes (in $) in Kuwait and Taxes (in $) in Suriname?
Your answer should be compact. -9.21e+08. In the year 2007, what is the difference between the Taxes (in $) in Bulgaria and Taxes (in $) in Cyprus?
Ensure brevity in your answer.  5.32e+09. In the year 2007, what is the difference between the Taxes (in $) of Bulgaria and Taxes (in $) of Kuwait?
Provide a short and direct response. 1.36e+1. In the year 2007, what is the difference between the Taxes (in $) in Bulgaria and Taxes (in $) in Suriname?
Keep it short and to the point. 1.24e+1. In the year 2007, what is the difference between the Taxes (in $) of Cyprus and Taxes (in $) of Kuwait?
Provide a short and direct response. 8.24e+09. In the year 2007, what is the difference between the Taxes (in $) of Cyprus and Taxes (in $) of Suriname?
Keep it short and to the point. 7.08e+09. In the year 2007, what is the difference between the Taxes (in $) in Kuwait and Taxes (in $) in Suriname?
Your answer should be very brief. -1.17e+09. In the year 2008, what is the difference between the Taxes (in $) of Bulgaria and Taxes (in $) of Cyprus?
Ensure brevity in your answer.  7.31e+09. In the year 2008, what is the difference between the Taxes (in $) of Bulgaria and Taxes (in $) of Kuwait?
Your answer should be compact. 1.58e+1. In the year 2008, what is the difference between the Taxes (in $) in Bulgaria and Taxes (in $) in Suriname?
Offer a terse response. 1.44e+1. In the year 2008, what is the difference between the Taxes (in $) in Cyprus and Taxes (in $) in Kuwait?
Provide a short and direct response. 8.47e+09. In the year 2008, what is the difference between the Taxes (in $) of Cyprus and Taxes (in $) of Suriname?
Offer a very short reply. 7.14e+09. In the year 2008, what is the difference between the Taxes (in $) in Kuwait and Taxes (in $) in Suriname?
Keep it short and to the point. -1.34e+09. In the year 2009, what is the difference between the Taxes (in $) in Bulgaria and Taxes (in $) in Cyprus?
Give a very brief answer. 9.99e+09. In the year 2009, what is the difference between the Taxes (in $) in Bulgaria and Taxes (in $) in Kuwait?
Provide a succinct answer. 1.41e+1. In the year 2009, what is the difference between the Taxes (in $) in Bulgaria and Taxes (in $) in Suriname?
Make the answer very short. 1.25e+1. In the year 2009, what is the difference between the Taxes (in $) in Cyprus and Taxes (in $) in Kuwait?
Make the answer very short. 4.07e+09. In the year 2009, what is the difference between the Taxes (in $) of Cyprus and Taxes (in $) of Suriname?
Your response must be concise. 2.54e+09. In the year 2009, what is the difference between the Taxes (in $) of Kuwait and Taxes (in $) of Suriname?
Ensure brevity in your answer.  -1.54e+09. In the year 2010, what is the difference between the Taxes (in $) of Bulgaria and Taxes (in $) of Cyprus?
Give a very brief answer. 8.98e+09. In the year 2010, what is the difference between the Taxes (in $) of Bulgaria and Taxes (in $) of Kuwait?
Your response must be concise. 1.32e+1. In the year 2010, what is the difference between the Taxes (in $) in Bulgaria and Taxes (in $) in Suriname?
Your answer should be very brief. 1.16e+1. In the year 2010, what is the difference between the Taxes (in $) of Cyprus and Taxes (in $) of Kuwait?
Keep it short and to the point. 4.19e+09. In the year 2010, what is the difference between the Taxes (in $) of Cyprus and Taxes (in $) of Suriname?
Keep it short and to the point. 2.64e+09. In the year 2010, what is the difference between the Taxes (in $) of Kuwait and Taxes (in $) of Suriname?
Provide a succinct answer. -1.55e+09. In the year 2011, what is the difference between the Taxes (in $) in Bulgaria and Taxes (in $) in Cyprus?
Make the answer very short. 9.73e+09. In the year 2011, what is the difference between the Taxes (in $) of Bulgaria and Taxes (in $) of Kuwait?
Your response must be concise. 1.40e+1. In the year 2011, what is the difference between the Taxes (in $) in Bulgaria and Taxes (in $) in Suriname?
Ensure brevity in your answer.  1.17e+1. In the year 2011, what is the difference between the Taxes (in $) of Cyprus and Taxes (in $) of Kuwait?
Make the answer very short. 4.28e+09. In the year 2011, what is the difference between the Taxes (in $) in Cyprus and Taxes (in $) in Suriname?
Your answer should be very brief. 1.95e+09. In the year 2011, what is the difference between the Taxes (in $) in Kuwait and Taxes (in $) in Suriname?
Your answer should be compact. -2.33e+09. What is the ratio of the Taxes (in $) in Bulgaria in 2004 to that in 2005?
Provide a succinct answer. 0.86. What is the ratio of the Taxes (in $) of Cyprus in 2004 to that in 2005?
Give a very brief answer. 0.89. What is the ratio of the Taxes (in $) in Kuwait in 2004 to that in 2005?
Your answer should be compact. 0.95. What is the ratio of the Taxes (in $) of Suriname in 2004 to that in 2005?
Provide a succinct answer. 0.85. What is the ratio of the Taxes (in $) of Bulgaria in 2004 to that in 2006?
Your response must be concise. 0.73. What is the ratio of the Taxes (in $) in Cyprus in 2004 to that in 2006?
Provide a succinct answer. 0.79. What is the ratio of the Taxes (in $) of Kuwait in 2004 to that in 2006?
Your answer should be very brief. 0.81. What is the ratio of the Taxes (in $) in Suriname in 2004 to that in 2006?
Ensure brevity in your answer.  0.71. What is the ratio of the Taxes (in $) in Bulgaria in 2004 to that in 2007?
Ensure brevity in your answer.  0.61. What is the ratio of the Taxes (in $) in Cyprus in 2004 to that in 2007?
Offer a terse response. 0.63. What is the ratio of the Taxes (in $) of Kuwait in 2004 to that in 2007?
Provide a succinct answer. 0.66. What is the ratio of the Taxes (in $) of Suriname in 2004 to that in 2007?
Provide a short and direct response. 0.56. What is the ratio of the Taxes (in $) in Bulgaria in 2004 to that in 2008?
Keep it short and to the point. 0.53. What is the ratio of the Taxes (in $) in Cyprus in 2004 to that in 2008?
Your answer should be compact. 0.61. What is the ratio of the Taxes (in $) in Kuwait in 2004 to that in 2008?
Give a very brief answer. 0.67. What is the ratio of the Taxes (in $) in Suriname in 2004 to that in 2008?
Provide a succinct answer. 0.51. What is the ratio of the Taxes (in $) in Bulgaria in 2004 to that in 2009?
Provide a succinct answer. 0.59. What is the ratio of the Taxes (in $) of Cyprus in 2004 to that in 2009?
Provide a short and direct response. 1.24. What is the ratio of the Taxes (in $) of Kuwait in 2004 to that in 2009?
Ensure brevity in your answer.  0.78. What is the ratio of the Taxes (in $) in Suriname in 2004 to that in 2009?
Make the answer very short. 0.47. What is the ratio of the Taxes (in $) of Bulgaria in 2004 to that in 2010?
Keep it short and to the point. 0.63. What is the ratio of the Taxes (in $) of Cyprus in 2004 to that in 2010?
Your answer should be very brief. 1.2. What is the ratio of the Taxes (in $) in Kuwait in 2004 to that in 2010?
Your answer should be compact. 0.72. What is the ratio of the Taxes (in $) in Suriname in 2004 to that in 2010?
Give a very brief answer. 0.45. What is the ratio of the Taxes (in $) in Bulgaria in 2004 to that in 2011?
Offer a terse response. 0.59. What is the ratio of the Taxes (in $) of Cyprus in 2004 to that in 2011?
Make the answer very short. 1.17. What is the ratio of the Taxes (in $) of Kuwait in 2004 to that in 2011?
Keep it short and to the point. 0.68. What is the ratio of the Taxes (in $) of Suriname in 2004 to that in 2011?
Keep it short and to the point. 0.32. What is the ratio of the Taxes (in $) in Bulgaria in 2005 to that in 2006?
Your response must be concise. 0.84. What is the ratio of the Taxes (in $) of Cyprus in 2005 to that in 2006?
Offer a very short reply. 0.89. What is the ratio of the Taxes (in $) of Kuwait in 2005 to that in 2006?
Your answer should be compact. 0.85. What is the ratio of the Taxes (in $) of Suriname in 2005 to that in 2006?
Keep it short and to the point. 0.83. What is the ratio of the Taxes (in $) in Bulgaria in 2005 to that in 2007?
Provide a succinct answer. 0.71. What is the ratio of the Taxes (in $) in Cyprus in 2005 to that in 2007?
Give a very brief answer. 0.71. What is the ratio of the Taxes (in $) in Kuwait in 2005 to that in 2007?
Make the answer very short. 0.69. What is the ratio of the Taxes (in $) in Suriname in 2005 to that in 2007?
Make the answer very short. 0.66. What is the ratio of the Taxes (in $) of Bulgaria in 2005 to that in 2008?
Offer a terse response. 0.61. What is the ratio of the Taxes (in $) of Cyprus in 2005 to that in 2008?
Give a very brief answer. 0.69. What is the ratio of the Taxes (in $) of Kuwait in 2005 to that in 2008?
Ensure brevity in your answer.  0.7. What is the ratio of the Taxes (in $) in Suriname in 2005 to that in 2008?
Your answer should be compact. 0.6. What is the ratio of the Taxes (in $) of Bulgaria in 2005 to that in 2009?
Your answer should be compact. 0.68. What is the ratio of the Taxes (in $) of Cyprus in 2005 to that in 2009?
Offer a terse response. 1.4. What is the ratio of the Taxes (in $) of Kuwait in 2005 to that in 2009?
Provide a succinct answer. 0.82. What is the ratio of the Taxes (in $) in Suriname in 2005 to that in 2009?
Give a very brief answer. 0.55. What is the ratio of the Taxes (in $) in Bulgaria in 2005 to that in 2010?
Your answer should be very brief. 0.73. What is the ratio of the Taxes (in $) of Cyprus in 2005 to that in 2010?
Provide a succinct answer. 1.35. What is the ratio of the Taxes (in $) in Kuwait in 2005 to that in 2010?
Your response must be concise. 0.75. What is the ratio of the Taxes (in $) of Suriname in 2005 to that in 2010?
Your response must be concise. 0.54. What is the ratio of the Taxes (in $) of Bulgaria in 2005 to that in 2011?
Provide a short and direct response. 0.69. What is the ratio of the Taxes (in $) of Cyprus in 2005 to that in 2011?
Make the answer very short. 1.32. What is the ratio of the Taxes (in $) of Kuwait in 2005 to that in 2011?
Make the answer very short. 0.71. What is the ratio of the Taxes (in $) in Suriname in 2005 to that in 2011?
Offer a terse response. 0.38. What is the ratio of the Taxes (in $) of Bulgaria in 2006 to that in 2007?
Give a very brief answer. 0.84. What is the ratio of the Taxes (in $) of Cyprus in 2006 to that in 2007?
Provide a short and direct response. 0.8. What is the ratio of the Taxes (in $) in Kuwait in 2006 to that in 2007?
Your response must be concise. 0.81. What is the ratio of the Taxes (in $) of Suriname in 2006 to that in 2007?
Your response must be concise. 0.79. What is the ratio of the Taxes (in $) in Bulgaria in 2006 to that in 2008?
Offer a very short reply. 0.72. What is the ratio of the Taxes (in $) in Cyprus in 2006 to that in 2008?
Offer a terse response. 0.78. What is the ratio of the Taxes (in $) of Kuwait in 2006 to that in 2008?
Offer a terse response. 0.82. What is the ratio of the Taxes (in $) in Suriname in 2006 to that in 2008?
Provide a succinct answer. 0.72. What is the ratio of the Taxes (in $) of Bulgaria in 2006 to that in 2009?
Your answer should be very brief. 0.81. What is the ratio of the Taxes (in $) in Cyprus in 2006 to that in 2009?
Ensure brevity in your answer.  1.58. What is the ratio of the Taxes (in $) in Kuwait in 2006 to that in 2009?
Your response must be concise. 0.97. What is the ratio of the Taxes (in $) of Suriname in 2006 to that in 2009?
Keep it short and to the point. 0.66. What is the ratio of the Taxes (in $) in Bulgaria in 2006 to that in 2010?
Keep it short and to the point. 0.86. What is the ratio of the Taxes (in $) in Cyprus in 2006 to that in 2010?
Your answer should be very brief. 1.52. What is the ratio of the Taxes (in $) of Kuwait in 2006 to that in 2010?
Keep it short and to the point. 0.88. What is the ratio of the Taxes (in $) in Suriname in 2006 to that in 2010?
Keep it short and to the point. 0.64. What is the ratio of the Taxes (in $) of Bulgaria in 2006 to that in 2011?
Give a very brief answer. 0.81. What is the ratio of the Taxes (in $) in Cyprus in 2006 to that in 2011?
Keep it short and to the point. 1.49. What is the ratio of the Taxes (in $) of Kuwait in 2006 to that in 2011?
Ensure brevity in your answer.  0.84. What is the ratio of the Taxes (in $) of Suriname in 2006 to that in 2011?
Make the answer very short. 0.45. What is the ratio of the Taxes (in $) of Bulgaria in 2007 to that in 2008?
Ensure brevity in your answer.  0.86. What is the ratio of the Taxes (in $) in Cyprus in 2007 to that in 2008?
Make the answer very short. 0.97. What is the ratio of the Taxes (in $) of Kuwait in 2007 to that in 2008?
Offer a terse response. 1.02. What is the ratio of the Taxes (in $) of Suriname in 2007 to that in 2008?
Offer a terse response. 0.9. What is the ratio of the Taxes (in $) of Bulgaria in 2007 to that in 2009?
Your answer should be very brief. 0.97. What is the ratio of the Taxes (in $) in Cyprus in 2007 to that in 2009?
Offer a terse response. 1.97. What is the ratio of the Taxes (in $) of Kuwait in 2007 to that in 2009?
Provide a succinct answer. 1.2. What is the ratio of the Taxes (in $) in Suriname in 2007 to that in 2009?
Give a very brief answer. 0.83. What is the ratio of the Taxes (in $) in Bulgaria in 2007 to that in 2010?
Your answer should be compact. 1.03. What is the ratio of the Taxes (in $) in Cyprus in 2007 to that in 2010?
Ensure brevity in your answer.  1.9. What is the ratio of the Taxes (in $) of Kuwait in 2007 to that in 2010?
Offer a terse response. 1.09. What is the ratio of the Taxes (in $) in Suriname in 2007 to that in 2010?
Your answer should be compact. 0.81. What is the ratio of the Taxes (in $) in Bulgaria in 2007 to that in 2011?
Your answer should be very brief. 0.97. What is the ratio of the Taxes (in $) in Cyprus in 2007 to that in 2011?
Make the answer very short. 1.86. What is the ratio of the Taxes (in $) in Kuwait in 2007 to that in 2011?
Give a very brief answer. 1.04. What is the ratio of the Taxes (in $) in Suriname in 2007 to that in 2011?
Make the answer very short. 0.57. What is the ratio of the Taxes (in $) in Bulgaria in 2008 to that in 2009?
Give a very brief answer. 1.12. What is the ratio of the Taxes (in $) of Cyprus in 2008 to that in 2009?
Provide a short and direct response. 2.02. What is the ratio of the Taxes (in $) of Kuwait in 2008 to that in 2009?
Keep it short and to the point. 1.17. What is the ratio of the Taxes (in $) of Suriname in 2008 to that in 2009?
Offer a terse response. 0.92. What is the ratio of the Taxes (in $) in Bulgaria in 2008 to that in 2010?
Keep it short and to the point. 1.19. What is the ratio of the Taxes (in $) in Cyprus in 2008 to that in 2010?
Your response must be concise. 1.95. What is the ratio of the Taxes (in $) in Kuwait in 2008 to that in 2010?
Give a very brief answer. 1.07. What is the ratio of the Taxes (in $) in Suriname in 2008 to that in 2010?
Your answer should be very brief. 0.9. What is the ratio of the Taxes (in $) in Bulgaria in 2008 to that in 2011?
Provide a succinct answer. 1.12. What is the ratio of the Taxes (in $) of Cyprus in 2008 to that in 2011?
Your answer should be compact. 1.91. What is the ratio of the Taxes (in $) in Kuwait in 2008 to that in 2011?
Make the answer very short. 1.02. What is the ratio of the Taxes (in $) of Suriname in 2008 to that in 2011?
Offer a terse response. 0.63. What is the ratio of the Taxes (in $) in Bulgaria in 2009 to that in 2010?
Ensure brevity in your answer.  1.06. What is the ratio of the Taxes (in $) of Cyprus in 2009 to that in 2010?
Ensure brevity in your answer.  0.97. What is the ratio of the Taxes (in $) of Kuwait in 2009 to that in 2010?
Offer a very short reply. 0.91. What is the ratio of the Taxes (in $) in Suriname in 2009 to that in 2010?
Your response must be concise. 0.98. What is the ratio of the Taxes (in $) in Cyprus in 2009 to that in 2011?
Offer a terse response. 0.94. What is the ratio of the Taxes (in $) of Kuwait in 2009 to that in 2011?
Offer a very short reply. 0.87. What is the ratio of the Taxes (in $) of Suriname in 2009 to that in 2011?
Keep it short and to the point. 0.69. What is the ratio of the Taxes (in $) of Bulgaria in 2010 to that in 2011?
Provide a short and direct response. 0.94. What is the ratio of the Taxes (in $) of Cyprus in 2010 to that in 2011?
Give a very brief answer. 0.98. What is the ratio of the Taxes (in $) in Kuwait in 2010 to that in 2011?
Your answer should be very brief. 0.95. What is the ratio of the Taxes (in $) of Suriname in 2010 to that in 2011?
Provide a succinct answer. 0.7. What is the difference between the highest and the second highest Taxes (in $) of Bulgaria?
Your response must be concise. 1.77e+09. What is the difference between the highest and the second highest Taxes (in $) of Cyprus?
Ensure brevity in your answer.  2.21e+08. What is the difference between the highest and the second highest Taxes (in $) of Suriname?
Provide a short and direct response. 7.89e+08. What is the difference between the highest and the lowest Taxes (in $) of Bulgaria?
Give a very brief answer. 7.65e+09. What is the difference between the highest and the lowest Taxes (in $) in Cyprus?
Your response must be concise. 4.45e+09. What is the difference between the highest and the lowest Taxes (in $) of Kuwait?
Your response must be concise. 1.22e+08. What is the difference between the highest and the lowest Taxes (in $) in Suriname?
Offer a terse response. 1.81e+09. 